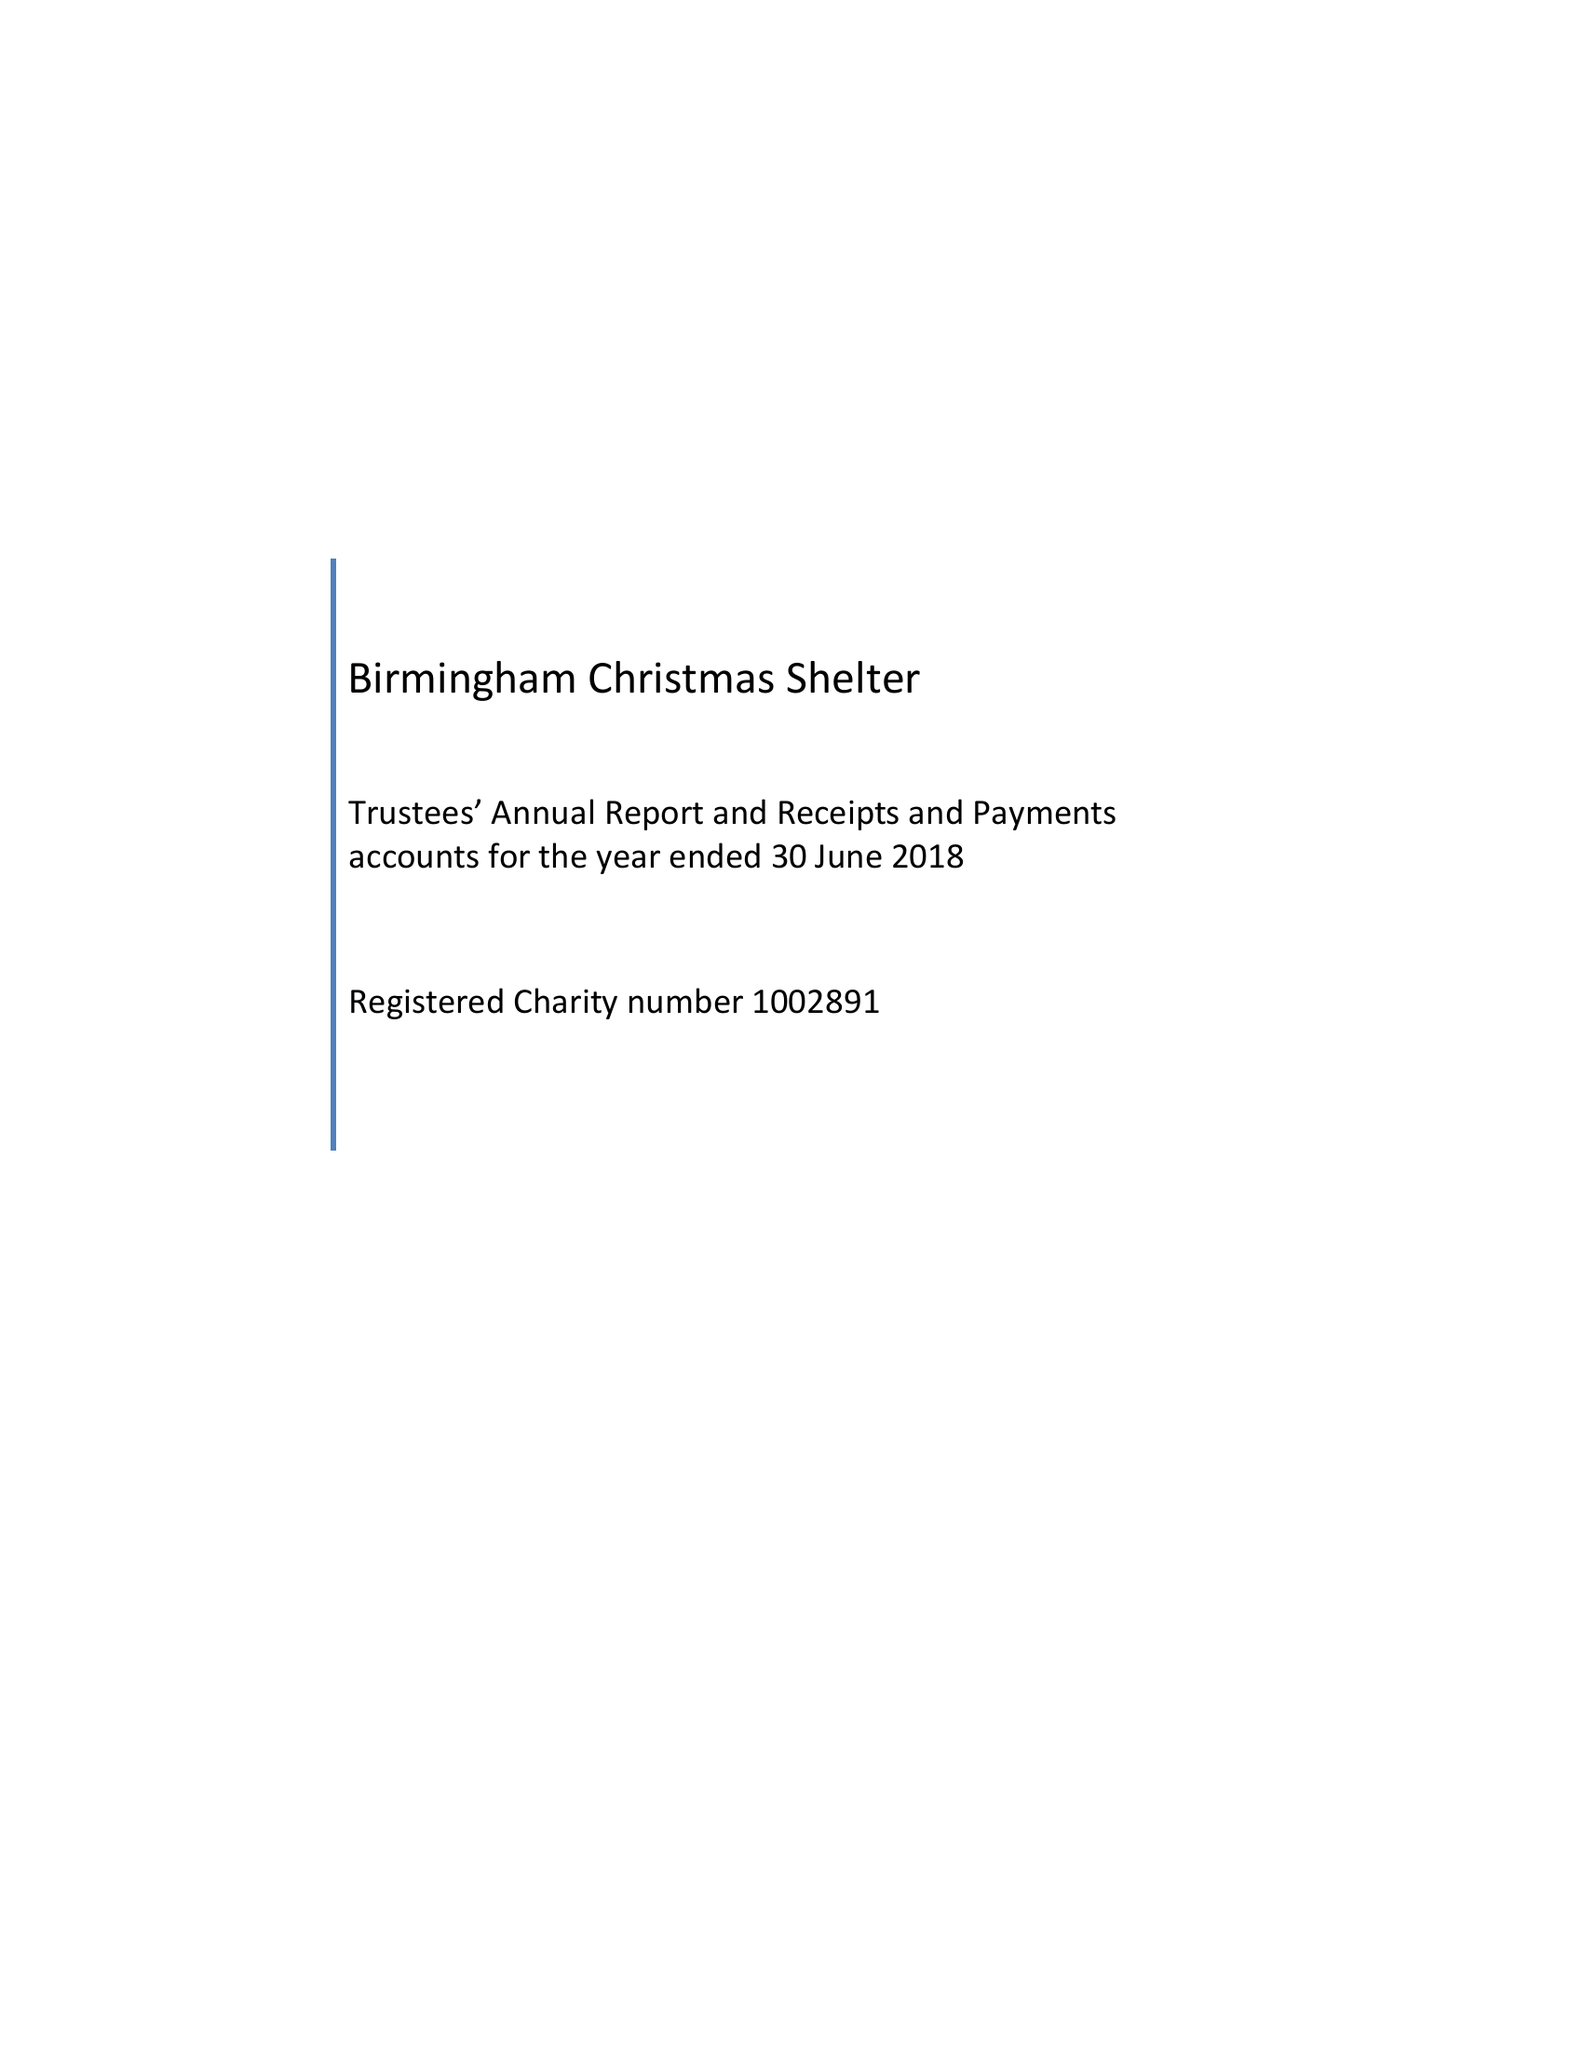What is the value for the spending_annually_in_british_pounds?
Answer the question using a single word or phrase. 28903.00 